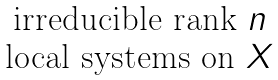Convert formula to latex. <formula><loc_0><loc_0><loc_500><loc_500>\begin{matrix} \text {irreducible rank } n \\ \text {local systems on } X \end{matrix}</formula> 